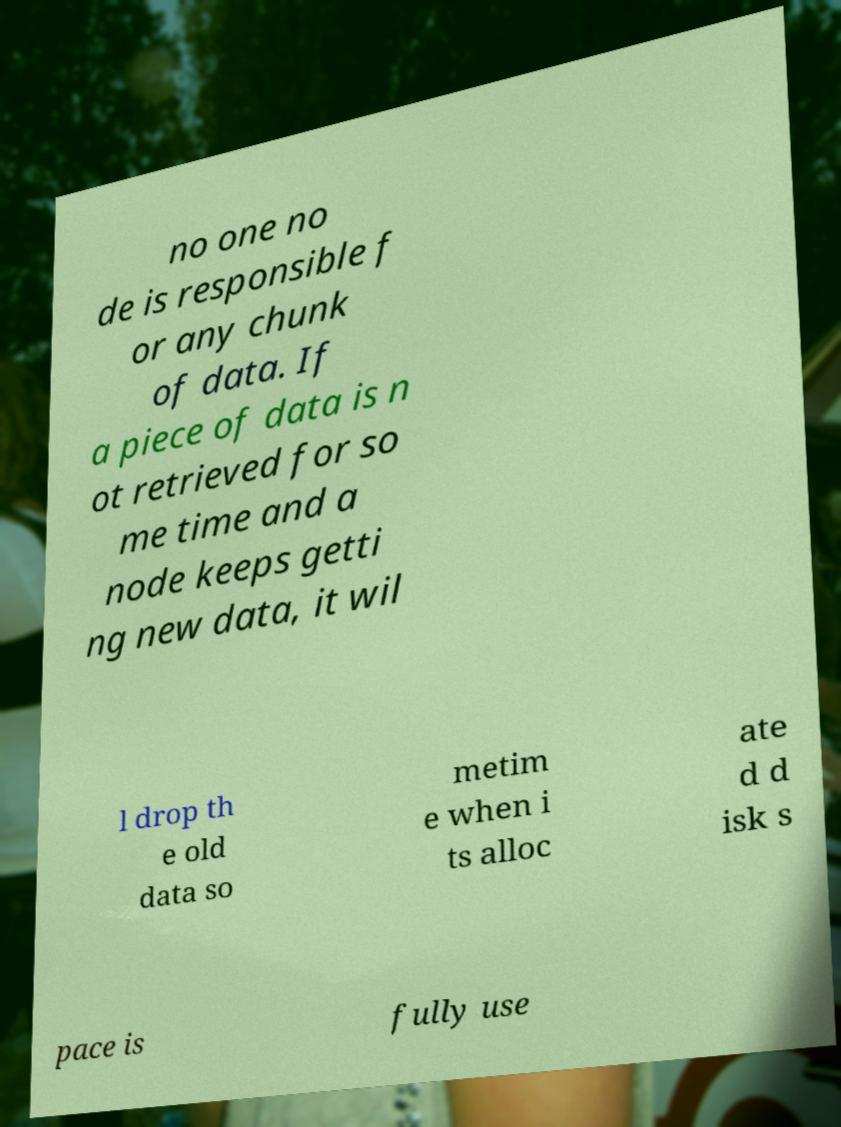Can you read and provide the text displayed in the image?This photo seems to have some interesting text. Can you extract and type it out for me? no one no de is responsible f or any chunk of data. If a piece of data is n ot retrieved for so me time and a node keeps getti ng new data, it wil l drop th e old data so metim e when i ts alloc ate d d isk s pace is fully use 